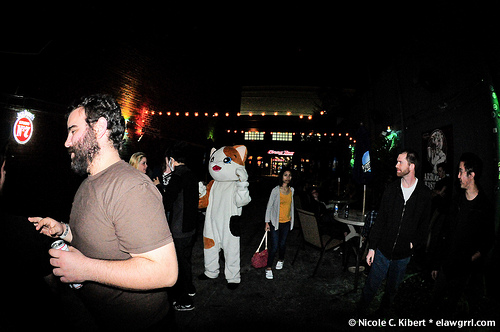<image>
Can you confirm if the cat is next to the woman? Yes. The cat is positioned adjacent to the woman, located nearby in the same general area. 